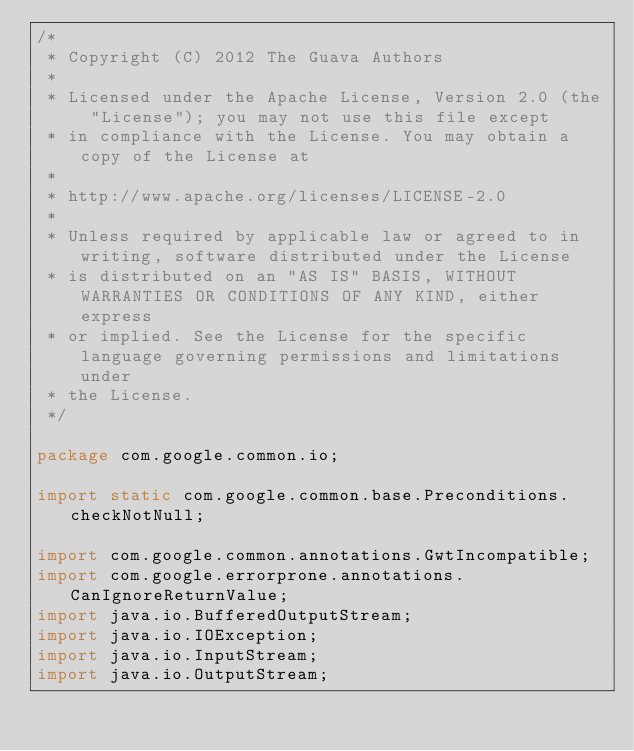<code> <loc_0><loc_0><loc_500><loc_500><_Java_>/*
 * Copyright (C) 2012 The Guava Authors
 *
 * Licensed under the Apache License, Version 2.0 (the "License"); you may not use this file except
 * in compliance with the License. You may obtain a copy of the License at
 *
 * http://www.apache.org/licenses/LICENSE-2.0
 *
 * Unless required by applicable law or agreed to in writing, software distributed under the License
 * is distributed on an "AS IS" BASIS, WITHOUT WARRANTIES OR CONDITIONS OF ANY KIND, either express
 * or implied. See the License for the specific language governing permissions and limitations under
 * the License.
 */

package com.google.common.io;

import static com.google.common.base.Preconditions.checkNotNull;

import com.google.common.annotations.GwtIncompatible;
import com.google.errorprone.annotations.CanIgnoreReturnValue;
import java.io.BufferedOutputStream;
import java.io.IOException;
import java.io.InputStream;
import java.io.OutputStream;</code> 